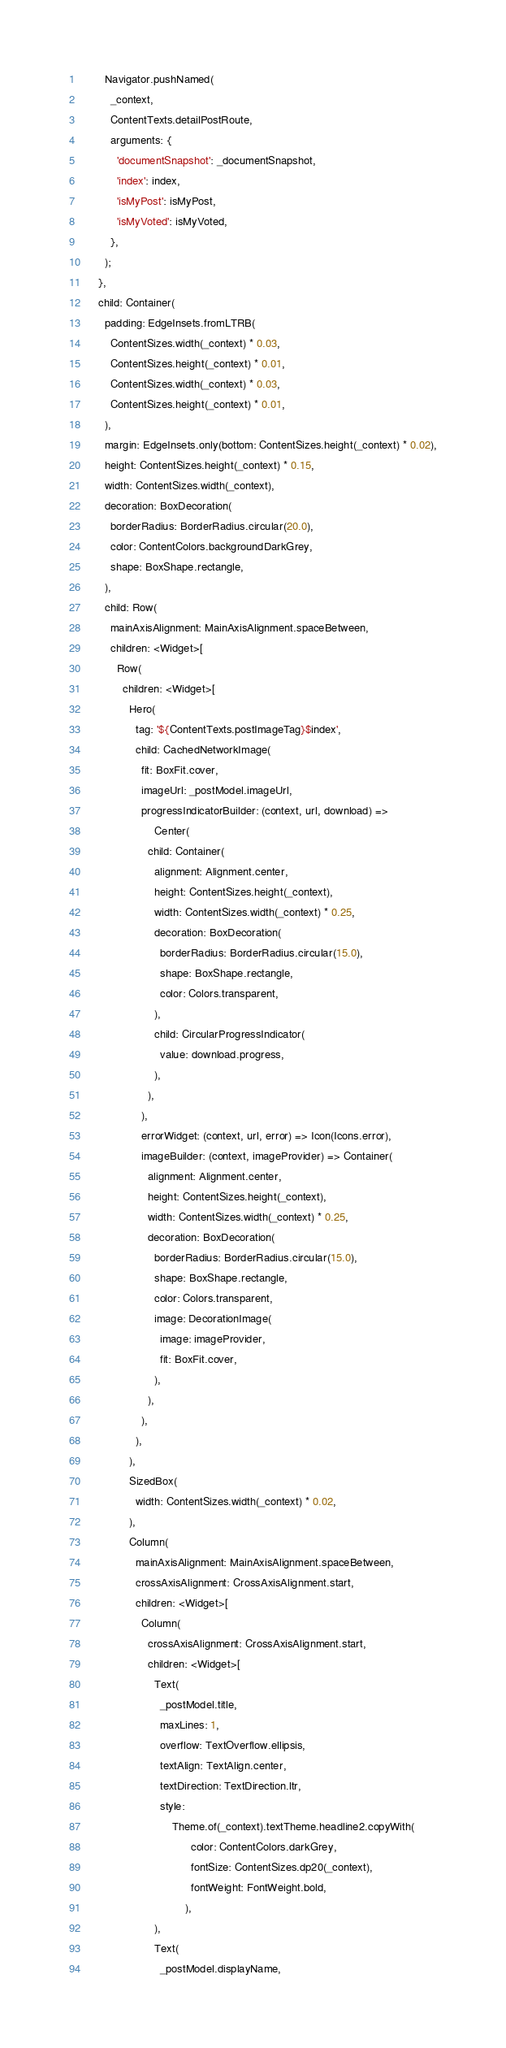Convert code to text. <code><loc_0><loc_0><loc_500><loc_500><_Dart_>        Navigator.pushNamed(
          _context,
          ContentTexts.detailPostRoute,
          arguments: {
            'documentSnapshot': _documentSnapshot,
            'index': index,
            'isMyPost': isMyPost,
            'isMyVoted': isMyVoted,
          },
        );
      },
      child: Container(
        padding: EdgeInsets.fromLTRB(
          ContentSizes.width(_context) * 0.03,
          ContentSizes.height(_context) * 0.01,
          ContentSizes.width(_context) * 0.03,
          ContentSizes.height(_context) * 0.01,
        ),
        margin: EdgeInsets.only(bottom: ContentSizes.height(_context) * 0.02),
        height: ContentSizes.height(_context) * 0.15,
        width: ContentSizes.width(_context),
        decoration: BoxDecoration(
          borderRadius: BorderRadius.circular(20.0),
          color: ContentColors.backgroundDarkGrey,
          shape: BoxShape.rectangle,
        ),
        child: Row(
          mainAxisAlignment: MainAxisAlignment.spaceBetween,
          children: <Widget>[
            Row(
              children: <Widget>[
                Hero(
                  tag: '${ContentTexts.postImageTag}$index',
                  child: CachedNetworkImage(
                    fit: BoxFit.cover,
                    imageUrl: _postModel.imageUrl,
                    progressIndicatorBuilder: (context, url, download) =>
                        Center(
                      child: Container(
                        alignment: Alignment.center,
                        height: ContentSizes.height(_context),
                        width: ContentSizes.width(_context) * 0.25,
                        decoration: BoxDecoration(
                          borderRadius: BorderRadius.circular(15.0),
                          shape: BoxShape.rectangle,
                          color: Colors.transparent,
                        ),
                        child: CircularProgressIndicator(
                          value: download.progress,
                        ),
                      ),
                    ),
                    errorWidget: (context, url, error) => Icon(Icons.error),
                    imageBuilder: (context, imageProvider) => Container(
                      alignment: Alignment.center,
                      height: ContentSizes.height(_context),
                      width: ContentSizes.width(_context) * 0.25,
                      decoration: BoxDecoration(
                        borderRadius: BorderRadius.circular(15.0),
                        shape: BoxShape.rectangle,
                        color: Colors.transparent,
                        image: DecorationImage(
                          image: imageProvider,
                          fit: BoxFit.cover,
                        ),
                      ),
                    ),
                  ),
                ),
                SizedBox(
                  width: ContentSizes.width(_context) * 0.02,
                ),
                Column(
                  mainAxisAlignment: MainAxisAlignment.spaceBetween,
                  crossAxisAlignment: CrossAxisAlignment.start,
                  children: <Widget>[
                    Column(
                      crossAxisAlignment: CrossAxisAlignment.start,
                      children: <Widget>[
                        Text(
                          _postModel.title,
                          maxLines: 1,
                          overflow: TextOverflow.ellipsis,
                          textAlign: TextAlign.center,
                          textDirection: TextDirection.ltr,
                          style:
                              Theme.of(_context).textTheme.headline2.copyWith(
                                    color: ContentColors.darkGrey,
                                    fontSize: ContentSizes.dp20(_context),
                                    fontWeight: FontWeight.bold,
                                  ),
                        ),
                        Text(
                          _postModel.displayName,</code> 